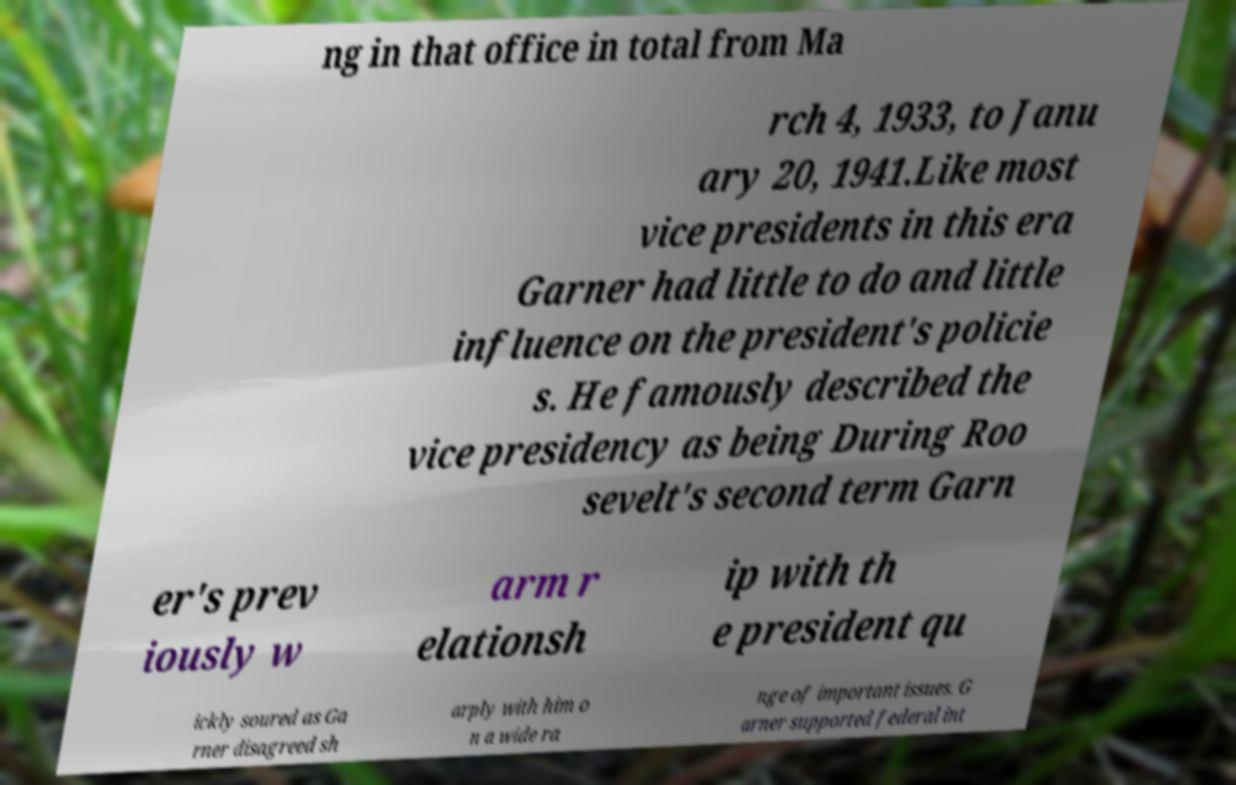Could you extract and type out the text from this image? ng in that office in total from Ma rch 4, 1933, to Janu ary 20, 1941.Like most vice presidents in this era Garner had little to do and little influence on the president's policie s. He famously described the vice presidency as being During Roo sevelt's second term Garn er's prev iously w arm r elationsh ip with th e president qu ickly soured as Ga rner disagreed sh arply with him o n a wide ra nge of important issues. G arner supported federal int 